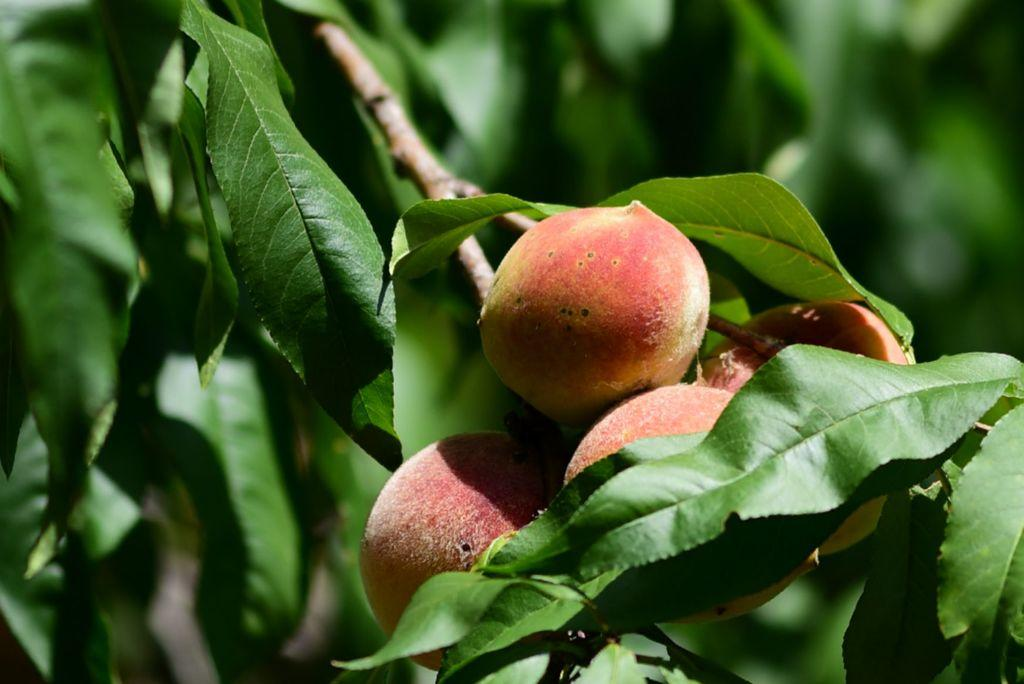What is present in the image? There is a plant in the image. What can be observed about the plant's fruits? The plant has fruits. What is the color of the plant's leaves? The plant has green leaves. Reasoning: Let'g: Let's think step by step in order to produce the conversation. We start by identifying the main subject in the image, which is the plant. Then, we expand the conversation to include specific details about the plant, such as the presence of fruits and the color of the leaves. Each question is designed to elicit a specific detail about the image that is known from the provided facts. Absurd Question/Answer: What grade does the rose receive in the image? There is no rose present in the image, so it cannot receive a grade. 